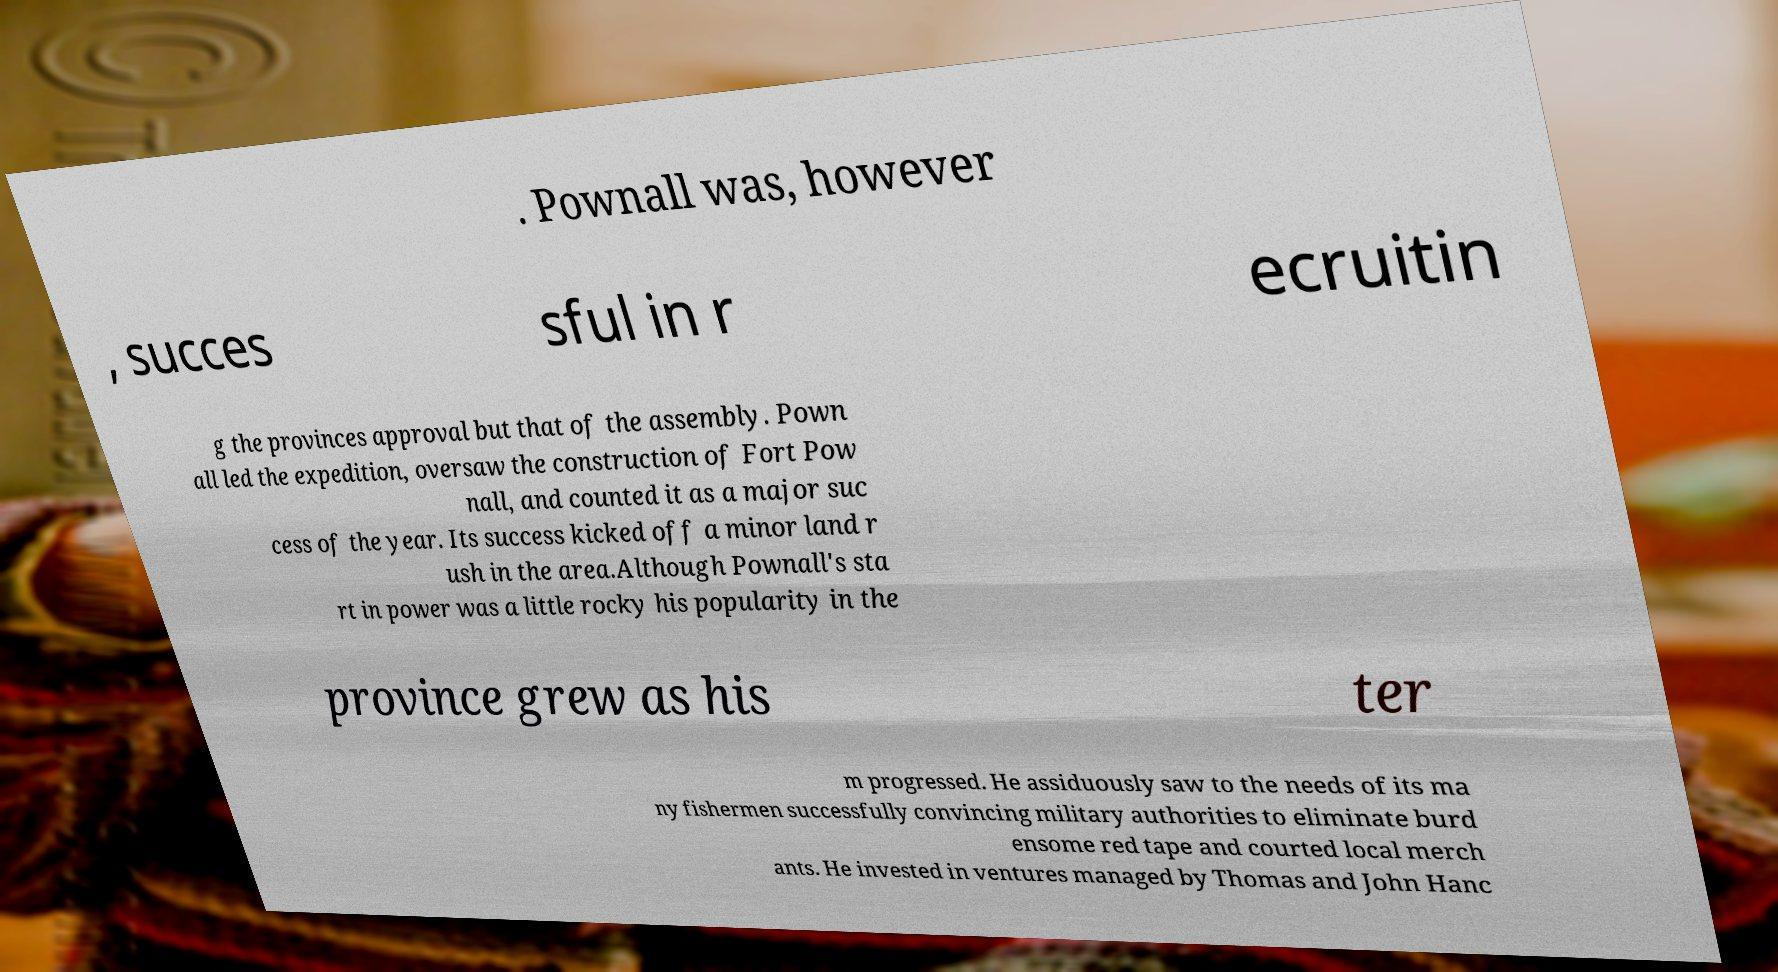Could you extract and type out the text from this image? . Pownall was, however , succes sful in r ecruitin g the provinces approval but that of the assembly. Pown all led the expedition, oversaw the construction of Fort Pow nall, and counted it as a major suc cess of the year. Its success kicked off a minor land r ush in the area.Although Pownall's sta rt in power was a little rocky his popularity in the province grew as his ter m progressed. He assiduously saw to the needs of its ma ny fishermen successfully convincing military authorities to eliminate burd ensome red tape and courted local merch ants. He invested in ventures managed by Thomas and John Hanc 